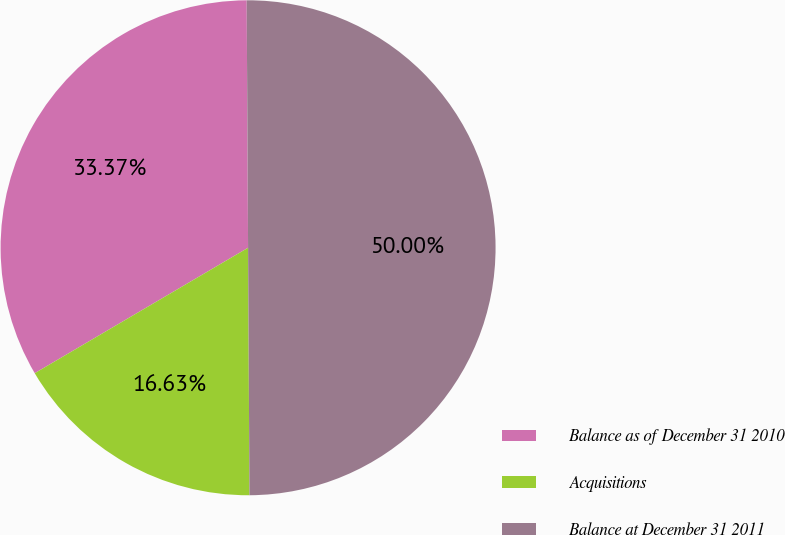<chart> <loc_0><loc_0><loc_500><loc_500><pie_chart><fcel>Balance as of December 31 2010<fcel>Acquisitions<fcel>Balance at December 31 2011<nl><fcel>33.37%<fcel>16.63%<fcel>50.0%<nl></chart> 